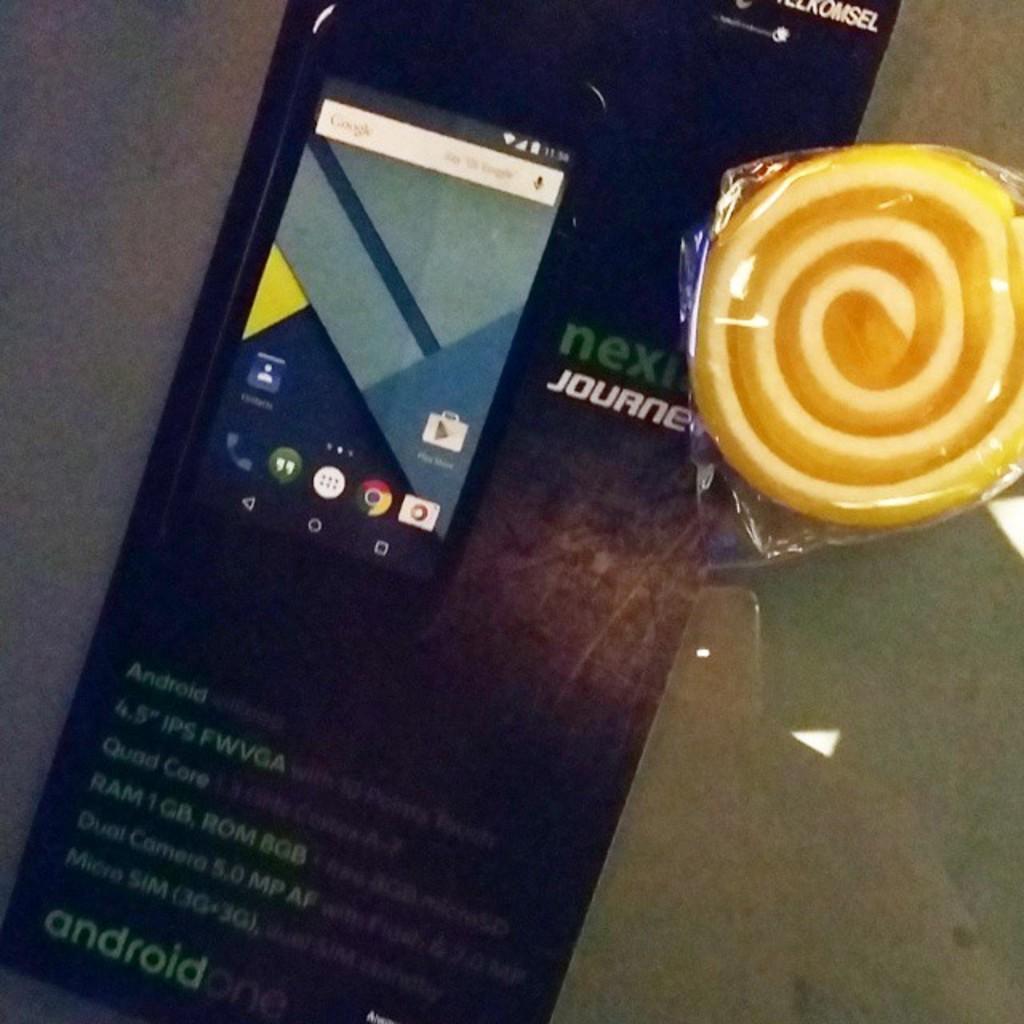Is that  phone magazine?
Provide a succinct answer. Yes. What operating system does this phone use?
Give a very brief answer. Android. 